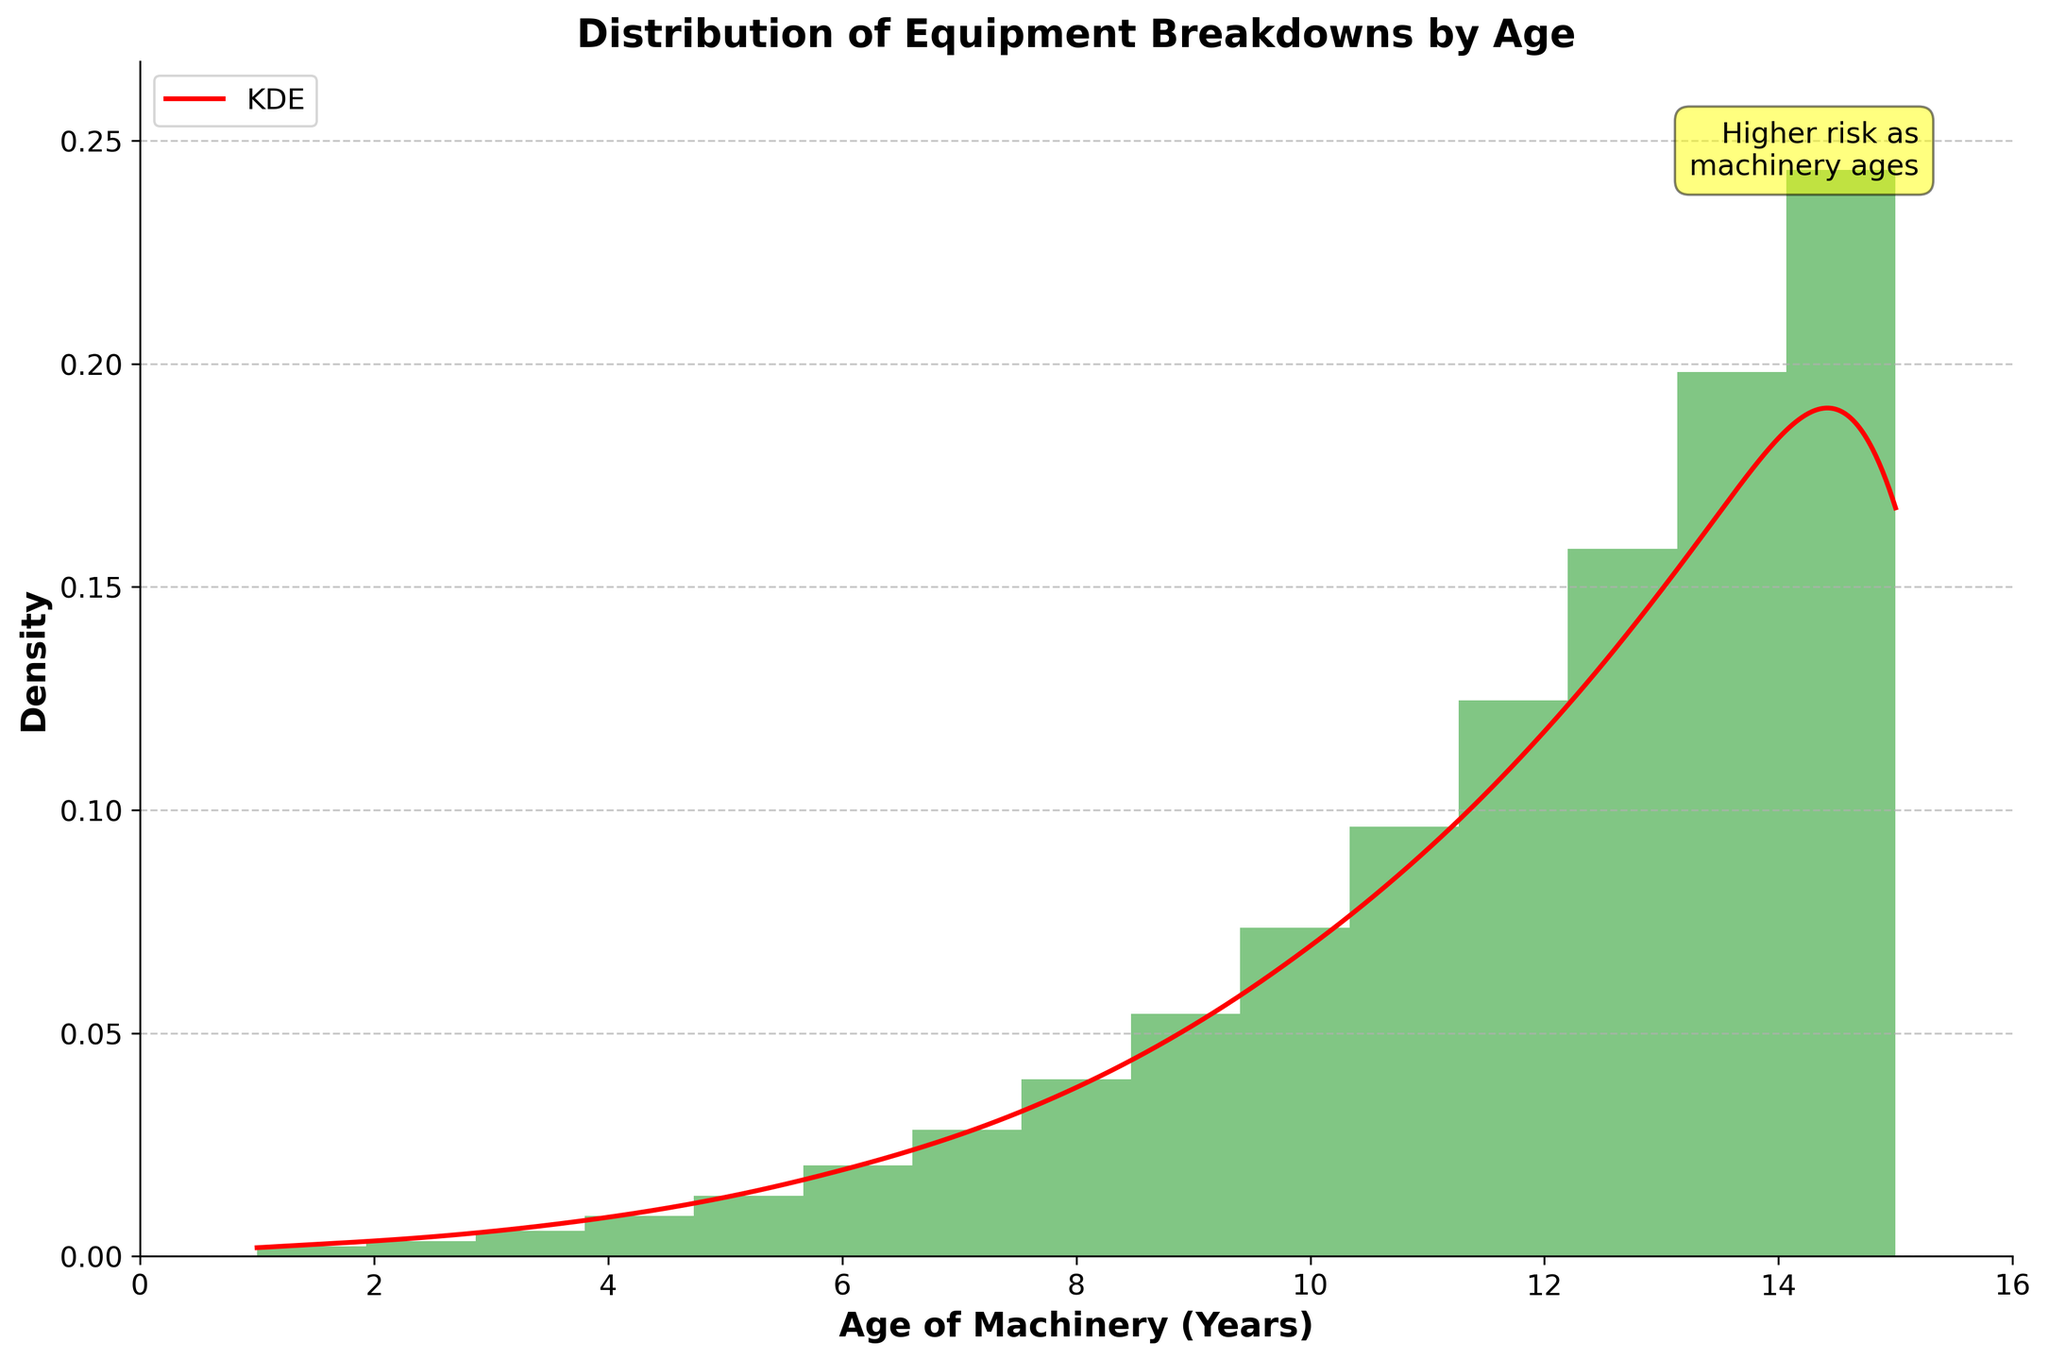How many bins does the histogram have? The figure displays a histogram which is divided into segments called bins. Each bin represents the frequency of breakdown occurrences within a specific age range. By counting the segments, we can determine the number of bins.
Answer: 15 What are the colors used in the histogram and KDE curve? The histogram uses green bars, and the KDE (density curve) is shown in a red line. The legend in the figure helps in identifying these elements.
Answer: Green and red What does the highest bar in the histogram represent? The highest bar represents the highest frequency of breakdowns for a certain machinery age range. By examining the figure, the highest bar corresponds to the oldest machinery, where age is around 15 years. This correlates to the highest density of breakdowns.
Answer: The oldest machinery (around age 15) What is the general trend shown by the KDE curve? The KDE curve provides a smooth estimate of the probability density function of the data. Observing the KDE curve in the figure, it consistently rises as the age of machinery increases, indicating that breakdown frequency is higher with the aging of the machinery.
Answer: Breakdown frequency increases with machinery age At what age does machinery start to have a significant risk of breakdown based on the density curve? To answer this, we look where the KDE curve begins to sharply rise. According to the figure, the KDE curve slopes upwards significantly starting around 5 years of age, indicating an increase in breakdown risk.
Answer: Around 5 years What is the average frequency of breakdowns for machinery aged 10 and below? To determine this, sum the breakdown frequencies for machinery from age 1 to 10 and then divide by the number of age points (10). Breakdown counts are: 2, 3, 5, 8, 12, 18, 25, 35, 48, 65. Sum = 221. Average = 221/10 = 22.1.
Answer: 22.1 How does the risk of breakdown for machinery aged 5 years compare to machinery aged 10 years? Refer to the KDE curve to compare the density at these ages. Visually, the density at 10 years is substantially higher than at 5 years, indicating a greater risk of breakdown.
Answer: Higher at 10 years than at 5 years Which age range has a density peak around 0.1 according to the KDE curve? Observing the KDE curve, the peak density value around 0.1 occurs between the machinery ages of roughly 8 to 10 years, indicating an increased breakdown risk within this age range.
Answer: 8 to 10 years What does the text annotation "Higher risk as machinery ages" imply regarding the histogram and KDE? The text annotation highlights the increasing trend of breakdown risk as machinery gets older, which is visually represented by the rising KDE curve and the increasing height of the histogram bars.
Answer: Breakdown risk rises with machinery age 